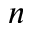Convert formula to latex. <formula><loc_0><loc_0><loc_500><loc_500>n</formula> 